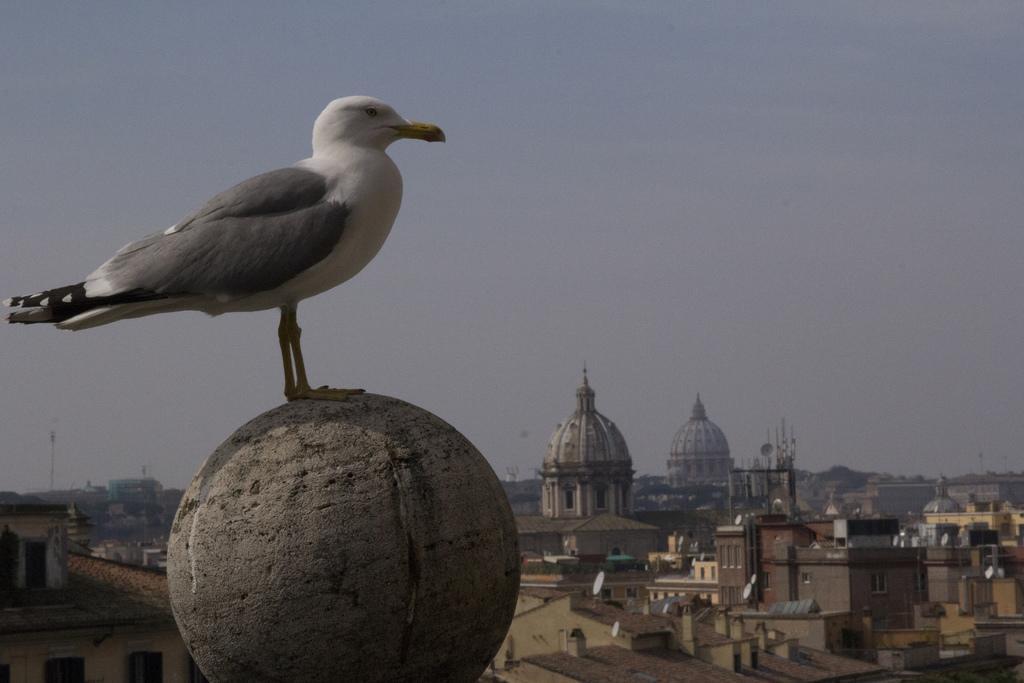Describe this image in one or two sentences. There is a bird standing on circular object. In the background we can see buildings, poles, satellite dishes and sky. 